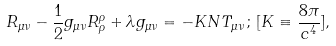<formula> <loc_0><loc_0><loc_500><loc_500>R _ { \mu \nu } - \frac { 1 } { 2 } g _ { \mu \nu } R ^ { \rho } _ { \rho } + \lambda g _ { \mu \nu } = - K N T _ { \mu \nu } \, ; \, [ K \equiv \frac { 8 \pi } { c ^ { 4 } } ] ,</formula> 